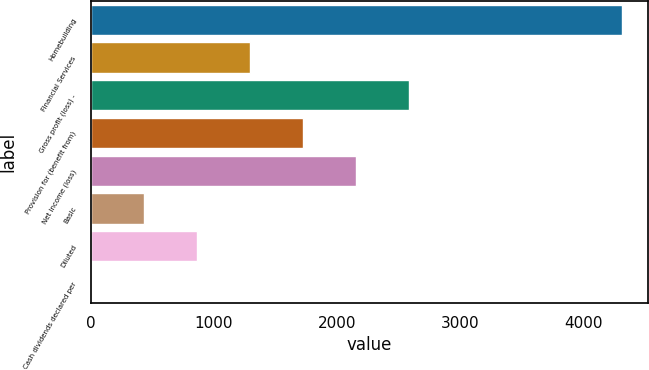Convert chart to OTSL. <chart><loc_0><loc_0><loc_500><loc_500><bar_chart><fcel>Homebuilding<fcel>Financial Services<fcel>Gross profit (loss) -<fcel>Provision for (benefit from)<fcel>Net income (loss)<fcel>Basic<fcel>Diluted<fcel>Cash dividends declared per<nl><fcel>4309.7<fcel>1293.03<fcel>2585.9<fcel>1723.99<fcel>2154.95<fcel>431.11<fcel>862.07<fcel>0.15<nl></chart> 